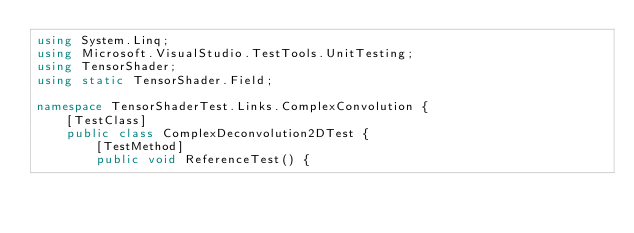Convert code to text. <code><loc_0><loc_0><loc_500><loc_500><_C#_>using System.Linq;
using Microsoft.VisualStudio.TestTools.UnitTesting;
using TensorShader;
using static TensorShader.Field;

namespace TensorShaderTest.Links.ComplexConvolution {
    [TestClass]
    public class ComplexDeconvolution2DTest {
        [TestMethod]
        public void ReferenceTest() {</code> 